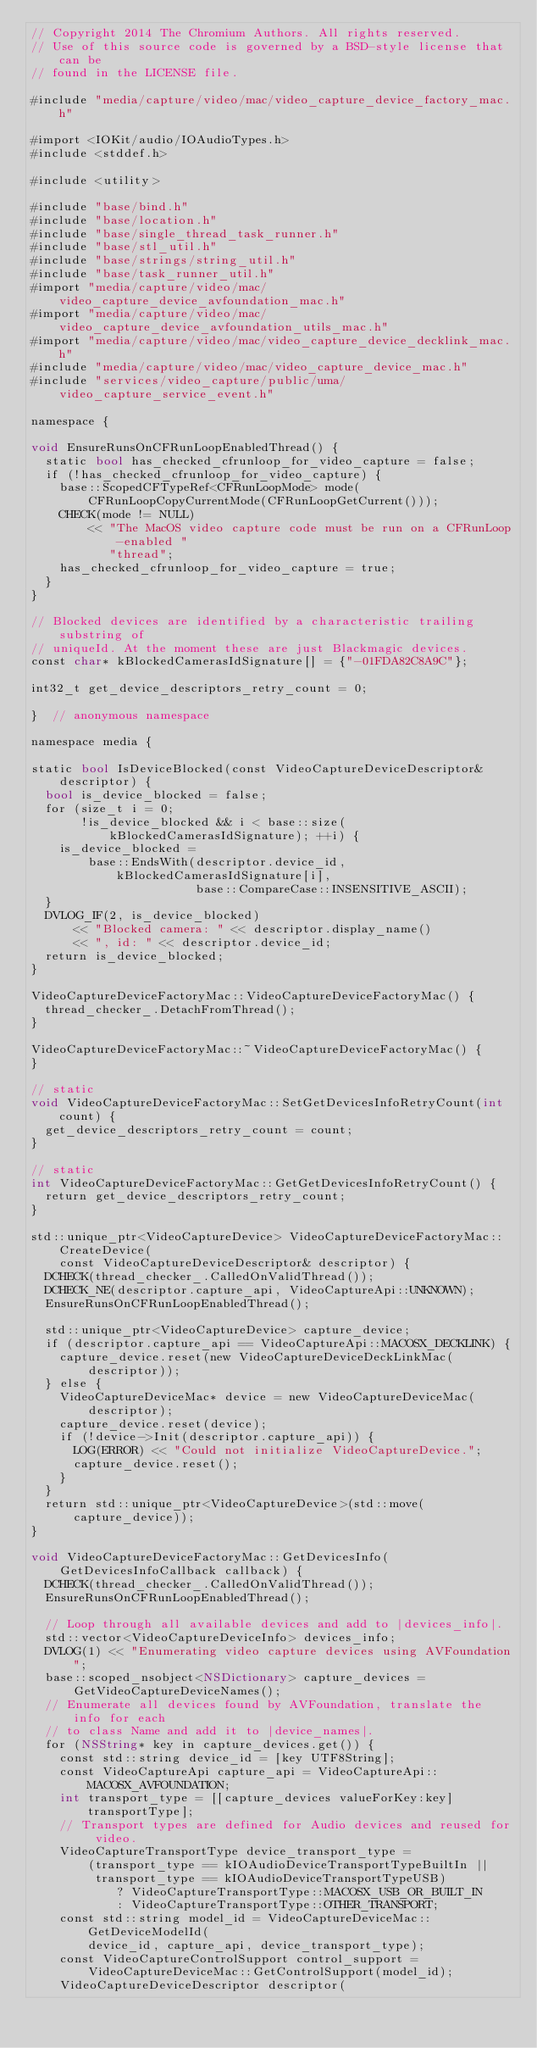Convert code to text. <code><loc_0><loc_0><loc_500><loc_500><_ObjectiveC_>// Copyright 2014 The Chromium Authors. All rights reserved.
// Use of this source code is governed by a BSD-style license that can be
// found in the LICENSE file.

#include "media/capture/video/mac/video_capture_device_factory_mac.h"

#import <IOKit/audio/IOAudioTypes.h>
#include <stddef.h>

#include <utility>

#include "base/bind.h"
#include "base/location.h"
#include "base/single_thread_task_runner.h"
#include "base/stl_util.h"
#include "base/strings/string_util.h"
#include "base/task_runner_util.h"
#import "media/capture/video/mac/video_capture_device_avfoundation_mac.h"
#import "media/capture/video/mac/video_capture_device_avfoundation_utils_mac.h"
#import "media/capture/video/mac/video_capture_device_decklink_mac.h"
#include "media/capture/video/mac/video_capture_device_mac.h"
#include "services/video_capture/public/uma/video_capture_service_event.h"

namespace {

void EnsureRunsOnCFRunLoopEnabledThread() {
  static bool has_checked_cfrunloop_for_video_capture = false;
  if (!has_checked_cfrunloop_for_video_capture) {
    base::ScopedCFTypeRef<CFRunLoopMode> mode(
        CFRunLoopCopyCurrentMode(CFRunLoopGetCurrent()));
    CHECK(mode != NULL)
        << "The MacOS video capture code must be run on a CFRunLoop-enabled "
           "thread";
    has_checked_cfrunloop_for_video_capture = true;
  }
}

// Blocked devices are identified by a characteristic trailing substring of
// uniqueId. At the moment these are just Blackmagic devices.
const char* kBlockedCamerasIdSignature[] = {"-01FDA82C8A9C"};

int32_t get_device_descriptors_retry_count = 0;

}  // anonymous namespace

namespace media {

static bool IsDeviceBlocked(const VideoCaptureDeviceDescriptor& descriptor) {
  bool is_device_blocked = false;
  for (size_t i = 0;
       !is_device_blocked && i < base::size(kBlockedCamerasIdSignature); ++i) {
    is_device_blocked =
        base::EndsWith(descriptor.device_id, kBlockedCamerasIdSignature[i],
                       base::CompareCase::INSENSITIVE_ASCII);
  }
  DVLOG_IF(2, is_device_blocked)
      << "Blocked camera: " << descriptor.display_name()
      << ", id: " << descriptor.device_id;
  return is_device_blocked;
}

VideoCaptureDeviceFactoryMac::VideoCaptureDeviceFactoryMac() {
  thread_checker_.DetachFromThread();
}

VideoCaptureDeviceFactoryMac::~VideoCaptureDeviceFactoryMac() {
}

// static
void VideoCaptureDeviceFactoryMac::SetGetDevicesInfoRetryCount(int count) {
  get_device_descriptors_retry_count = count;
}

// static
int VideoCaptureDeviceFactoryMac::GetGetDevicesInfoRetryCount() {
  return get_device_descriptors_retry_count;
}

std::unique_ptr<VideoCaptureDevice> VideoCaptureDeviceFactoryMac::CreateDevice(
    const VideoCaptureDeviceDescriptor& descriptor) {
  DCHECK(thread_checker_.CalledOnValidThread());
  DCHECK_NE(descriptor.capture_api, VideoCaptureApi::UNKNOWN);
  EnsureRunsOnCFRunLoopEnabledThread();

  std::unique_ptr<VideoCaptureDevice> capture_device;
  if (descriptor.capture_api == VideoCaptureApi::MACOSX_DECKLINK) {
    capture_device.reset(new VideoCaptureDeviceDeckLinkMac(descriptor));
  } else {
    VideoCaptureDeviceMac* device = new VideoCaptureDeviceMac(descriptor);
    capture_device.reset(device);
    if (!device->Init(descriptor.capture_api)) {
      LOG(ERROR) << "Could not initialize VideoCaptureDevice.";
      capture_device.reset();
    }
  }
  return std::unique_ptr<VideoCaptureDevice>(std::move(capture_device));
}

void VideoCaptureDeviceFactoryMac::GetDevicesInfo(
    GetDevicesInfoCallback callback) {
  DCHECK(thread_checker_.CalledOnValidThread());
  EnsureRunsOnCFRunLoopEnabledThread();

  // Loop through all available devices and add to |devices_info|.
  std::vector<VideoCaptureDeviceInfo> devices_info;
  DVLOG(1) << "Enumerating video capture devices using AVFoundation";
  base::scoped_nsobject<NSDictionary> capture_devices =
      GetVideoCaptureDeviceNames();
  // Enumerate all devices found by AVFoundation, translate the info for each
  // to class Name and add it to |device_names|.
  for (NSString* key in capture_devices.get()) {
    const std::string device_id = [key UTF8String];
    const VideoCaptureApi capture_api = VideoCaptureApi::MACOSX_AVFOUNDATION;
    int transport_type = [[capture_devices valueForKey:key] transportType];
    // Transport types are defined for Audio devices and reused for video.
    VideoCaptureTransportType device_transport_type =
        (transport_type == kIOAudioDeviceTransportTypeBuiltIn ||
         transport_type == kIOAudioDeviceTransportTypeUSB)
            ? VideoCaptureTransportType::MACOSX_USB_OR_BUILT_IN
            : VideoCaptureTransportType::OTHER_TRANSPORT;
    const std::string model_id = VideoCaptureDeviceMac::GetDeviceModelId(
        device_id, capture_api, device_transport_type);
    const VideoCaptureControlSupport control_support =
        VideoCaptureDeviceMac::GetControlSupport(model_id);
    VideoCaptureDeviceDescriptor descriptor(</code> 